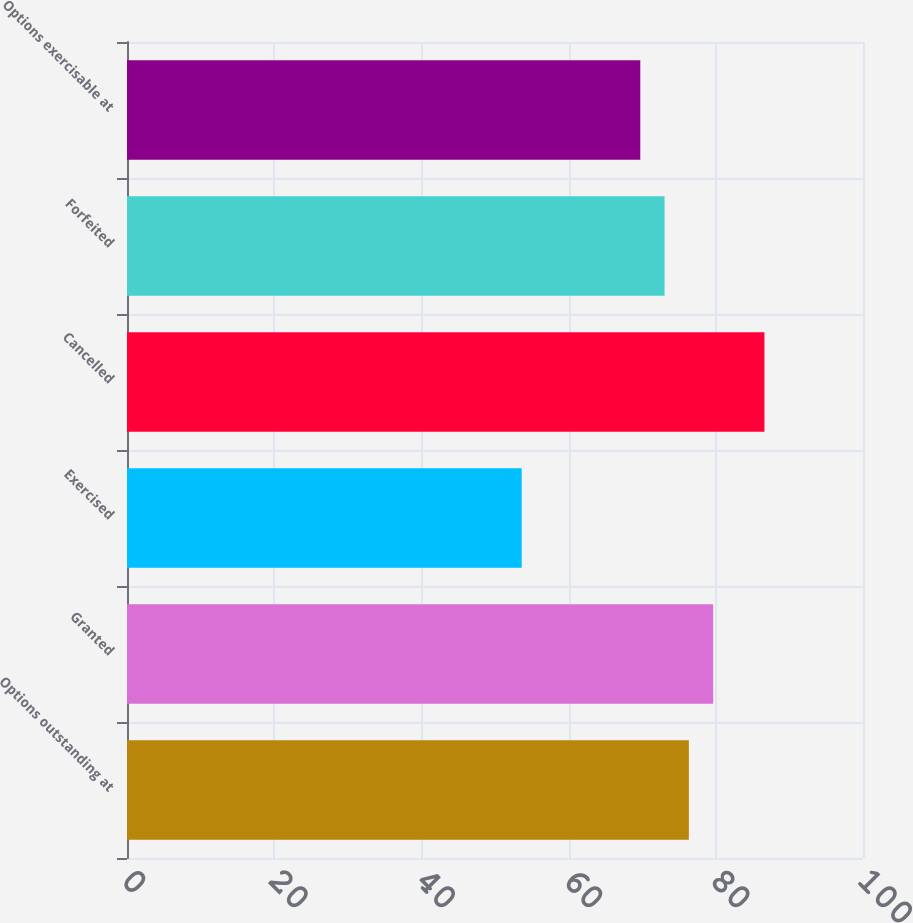Convert chart. <chart><loc_0><loc_0><loc_500><loc_500><bar_chart><fcel>Options outstanding at<fcel>Granted<fcel>Exercised<fcel>Cancelled<fcel>Forfeited<fcel>Options exercisable at<nl><fcel>76.34<fcel>79.64<fcel>53.63<fcel>86.61<fcel>73.04<fcel>69.74<nl></chart> 